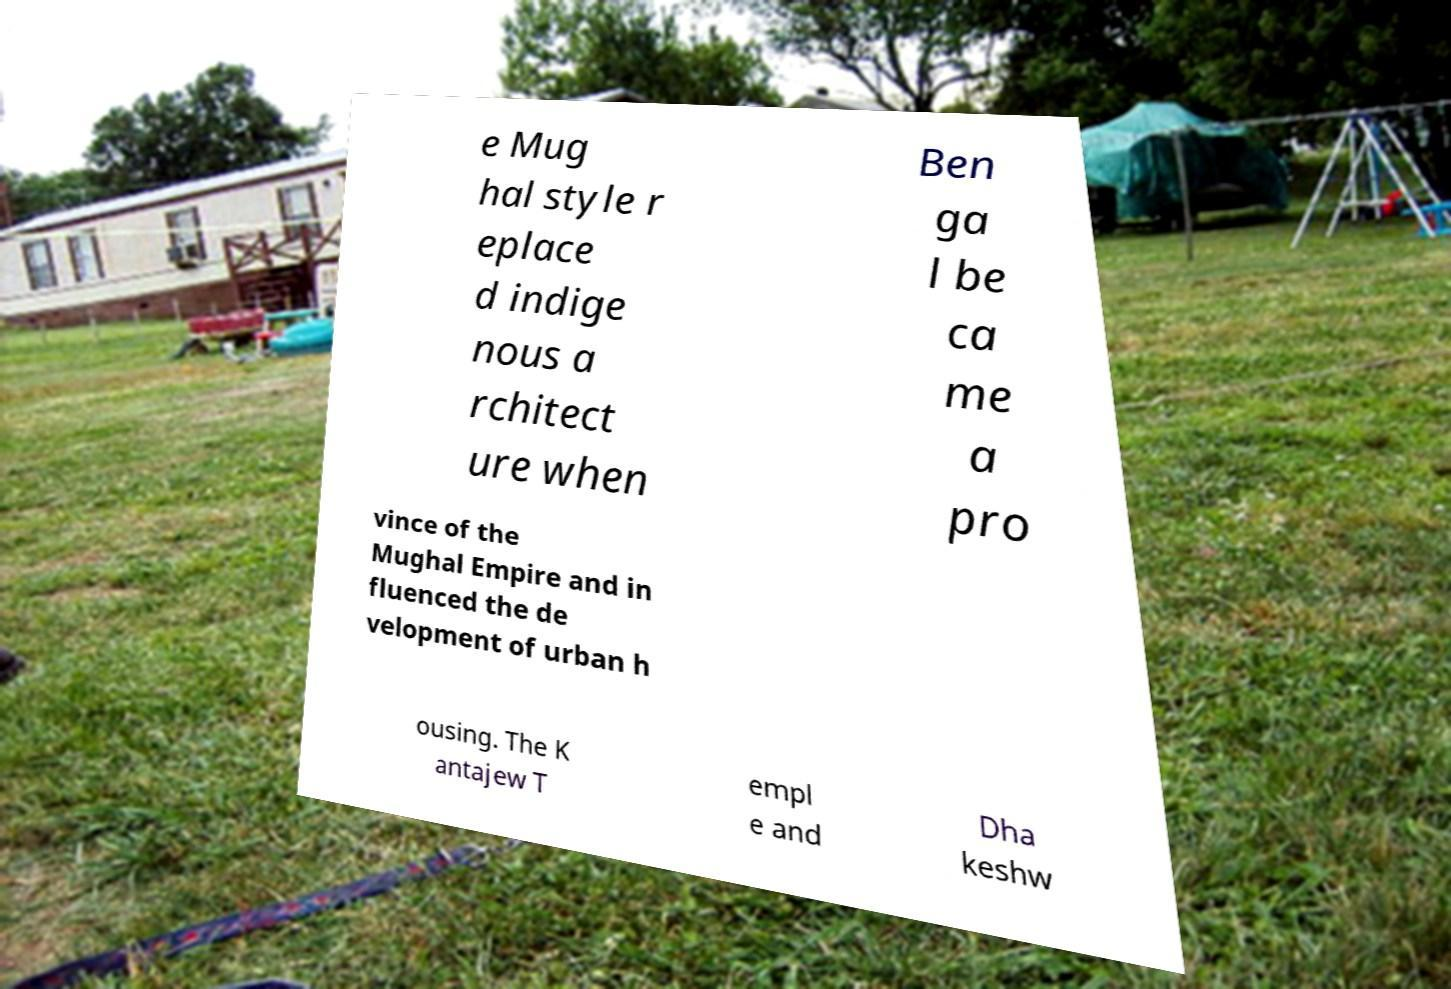Could you assist in decoding the text presented in this image and type it out clearly? e Mug hal style r eplace d indige nous a rchitect ure when Ben ga l be ca me a pro vince of the Mughal Empire and in fluenced the de velopment of urban h ousing. The K antajew T empl e and Dha keshw 